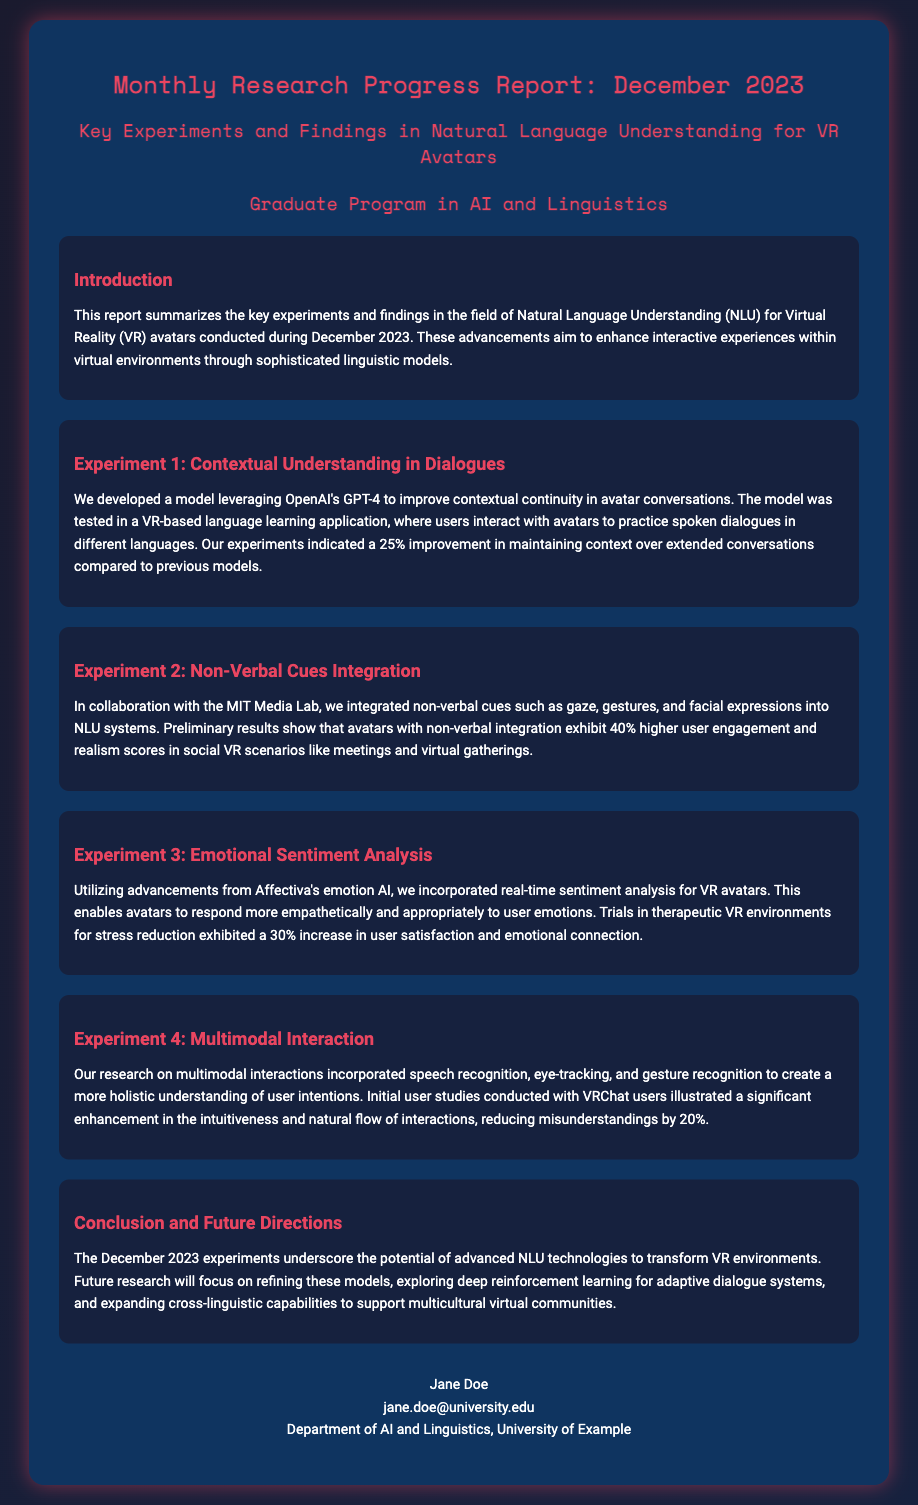What is the title of the report? The title of the report is prominently displayed at the beginning of the document.
Answer: Monthly Research Progress Report: December 2023 What experiment improved contextual continuity? The report specifies the focus of the first experiment regarding contextual continuity in dialogues.
Answer: Experiment 1: Contextual Understanding in Dialogues What percentage improvement was shown in maintaining context? The improvement percentage for maintaining context in the first experiment is stated clearly in the findings.
Answer: 25% Which lab collaborated on integrating non-verbal cues? The name of the collaborating lab for the second experiment is mentioned in the document.
Answer: MIT Media Lab What was the increase in user satisfaction for emotional sentiment analysis? The document includes specific user satisfaction metrics related to emotional sentiment analysis.
Answer: 30% What aspect was enhanced in multimodal interactions? The report describes the specific enhancement related to user interactions in the fourth experiment.
Answer: Intuitiveness and natural flow What is the focus of future research directions mentioned? Future research focus areas are outlined towards the end of the report.
Answer: Refining models, adaptive dialogue systems, cross-linguistic capabilities What type of environments were used to test emotional sentiment analysis? The document points out the specific context in which emotional sentiment analysis was trialed.
Answer: Therapeutic VR environments 